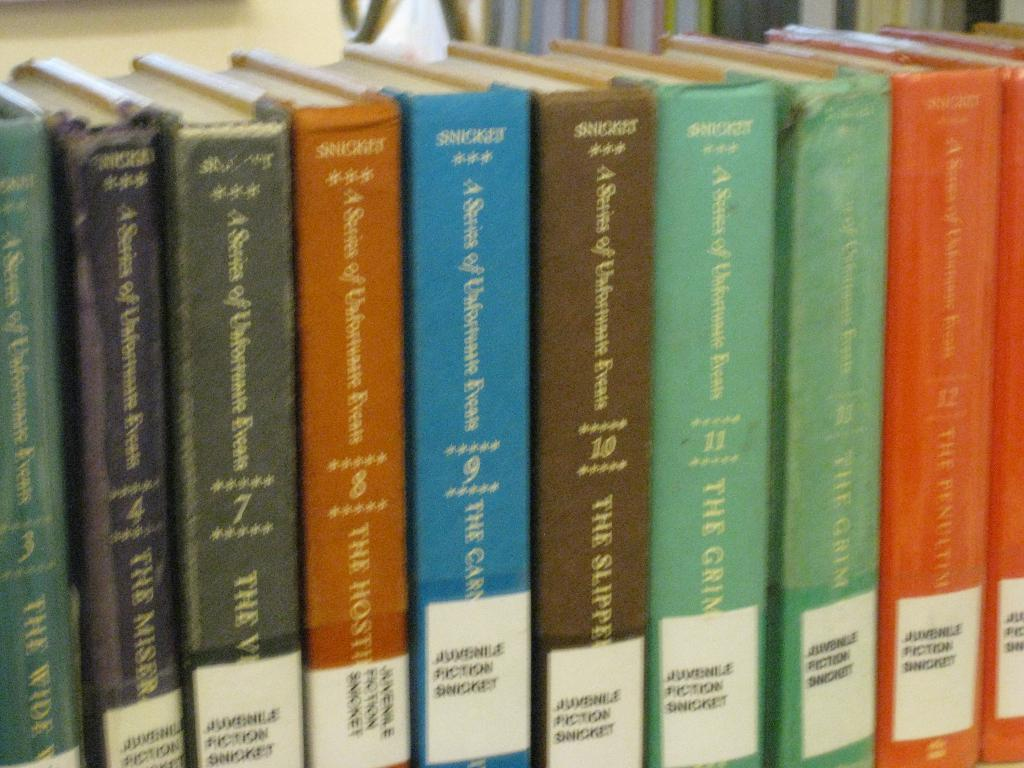<image>
Summarize the visual content of the image. Books are lined up and numbered with the first on being number three and the last visible on being number 12. 